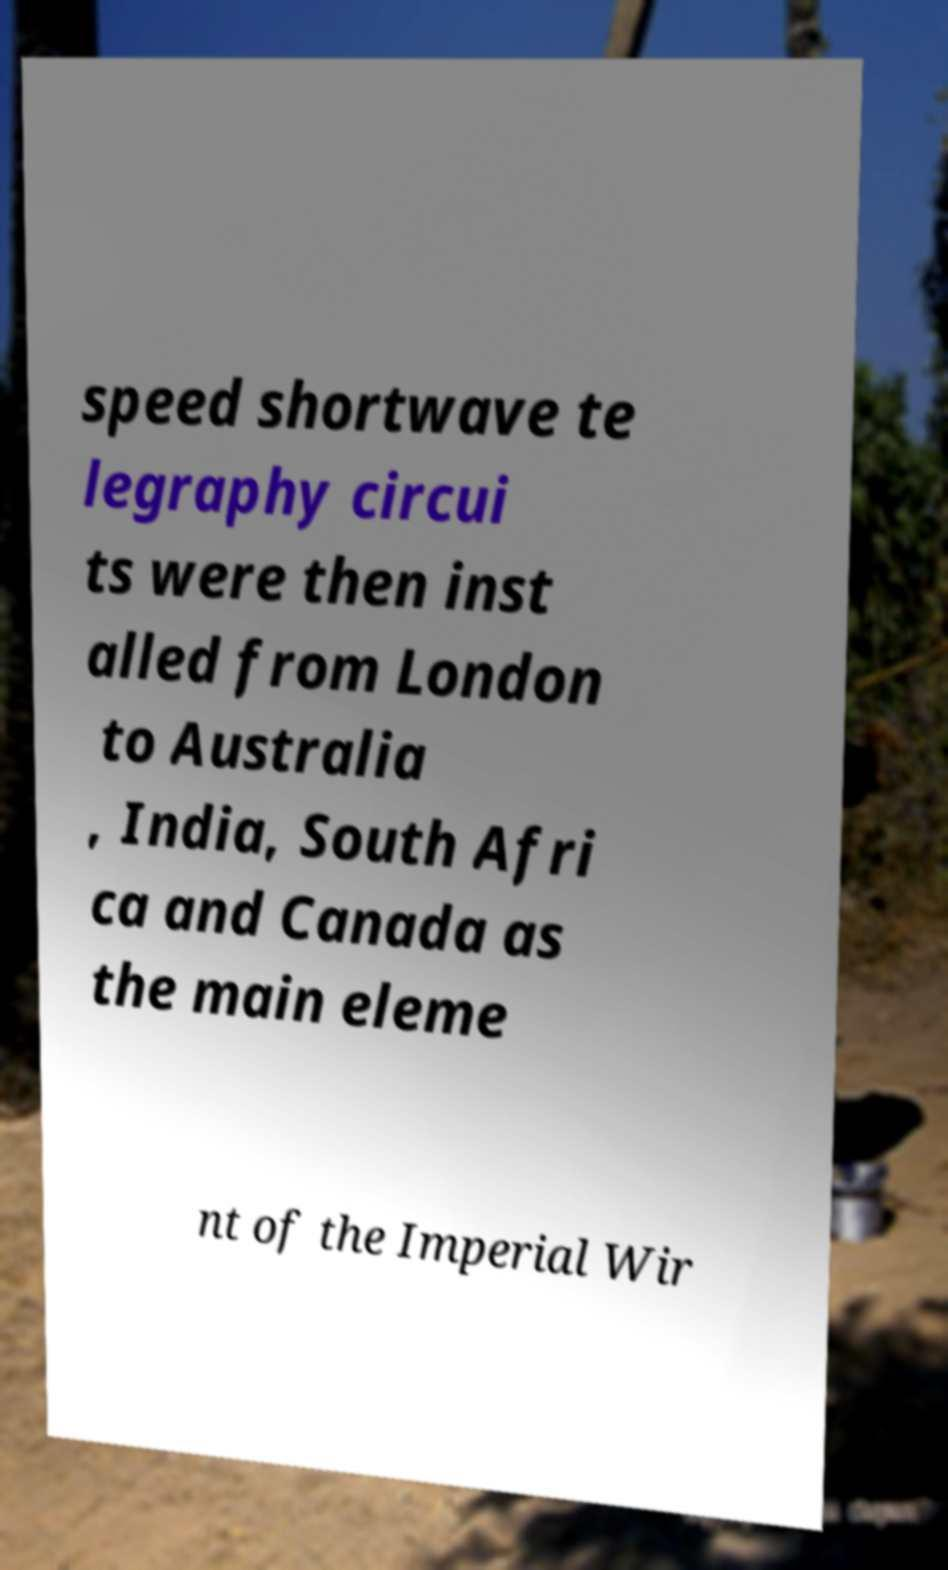Can you read and provide the text displayed in the image?This photo seems to have some interesting text. Can you extract and type it out for me? speed shortwave te legraphy circui ts were then inst alled from London to Australia , India, South Afri ca and Canada as the main eleme nt of the Imperial Wir 